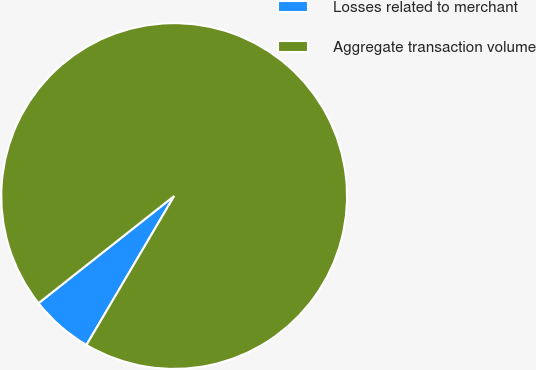Convert chart to OTSL. <chart><loc_0><loc_0><loc_500><loc_500><pie_chart><fcel>Losses related to merchant<fcel>Aggregate transaction volume<nl><fcel>5.89%<fcel>94.11%<nl></chart> 